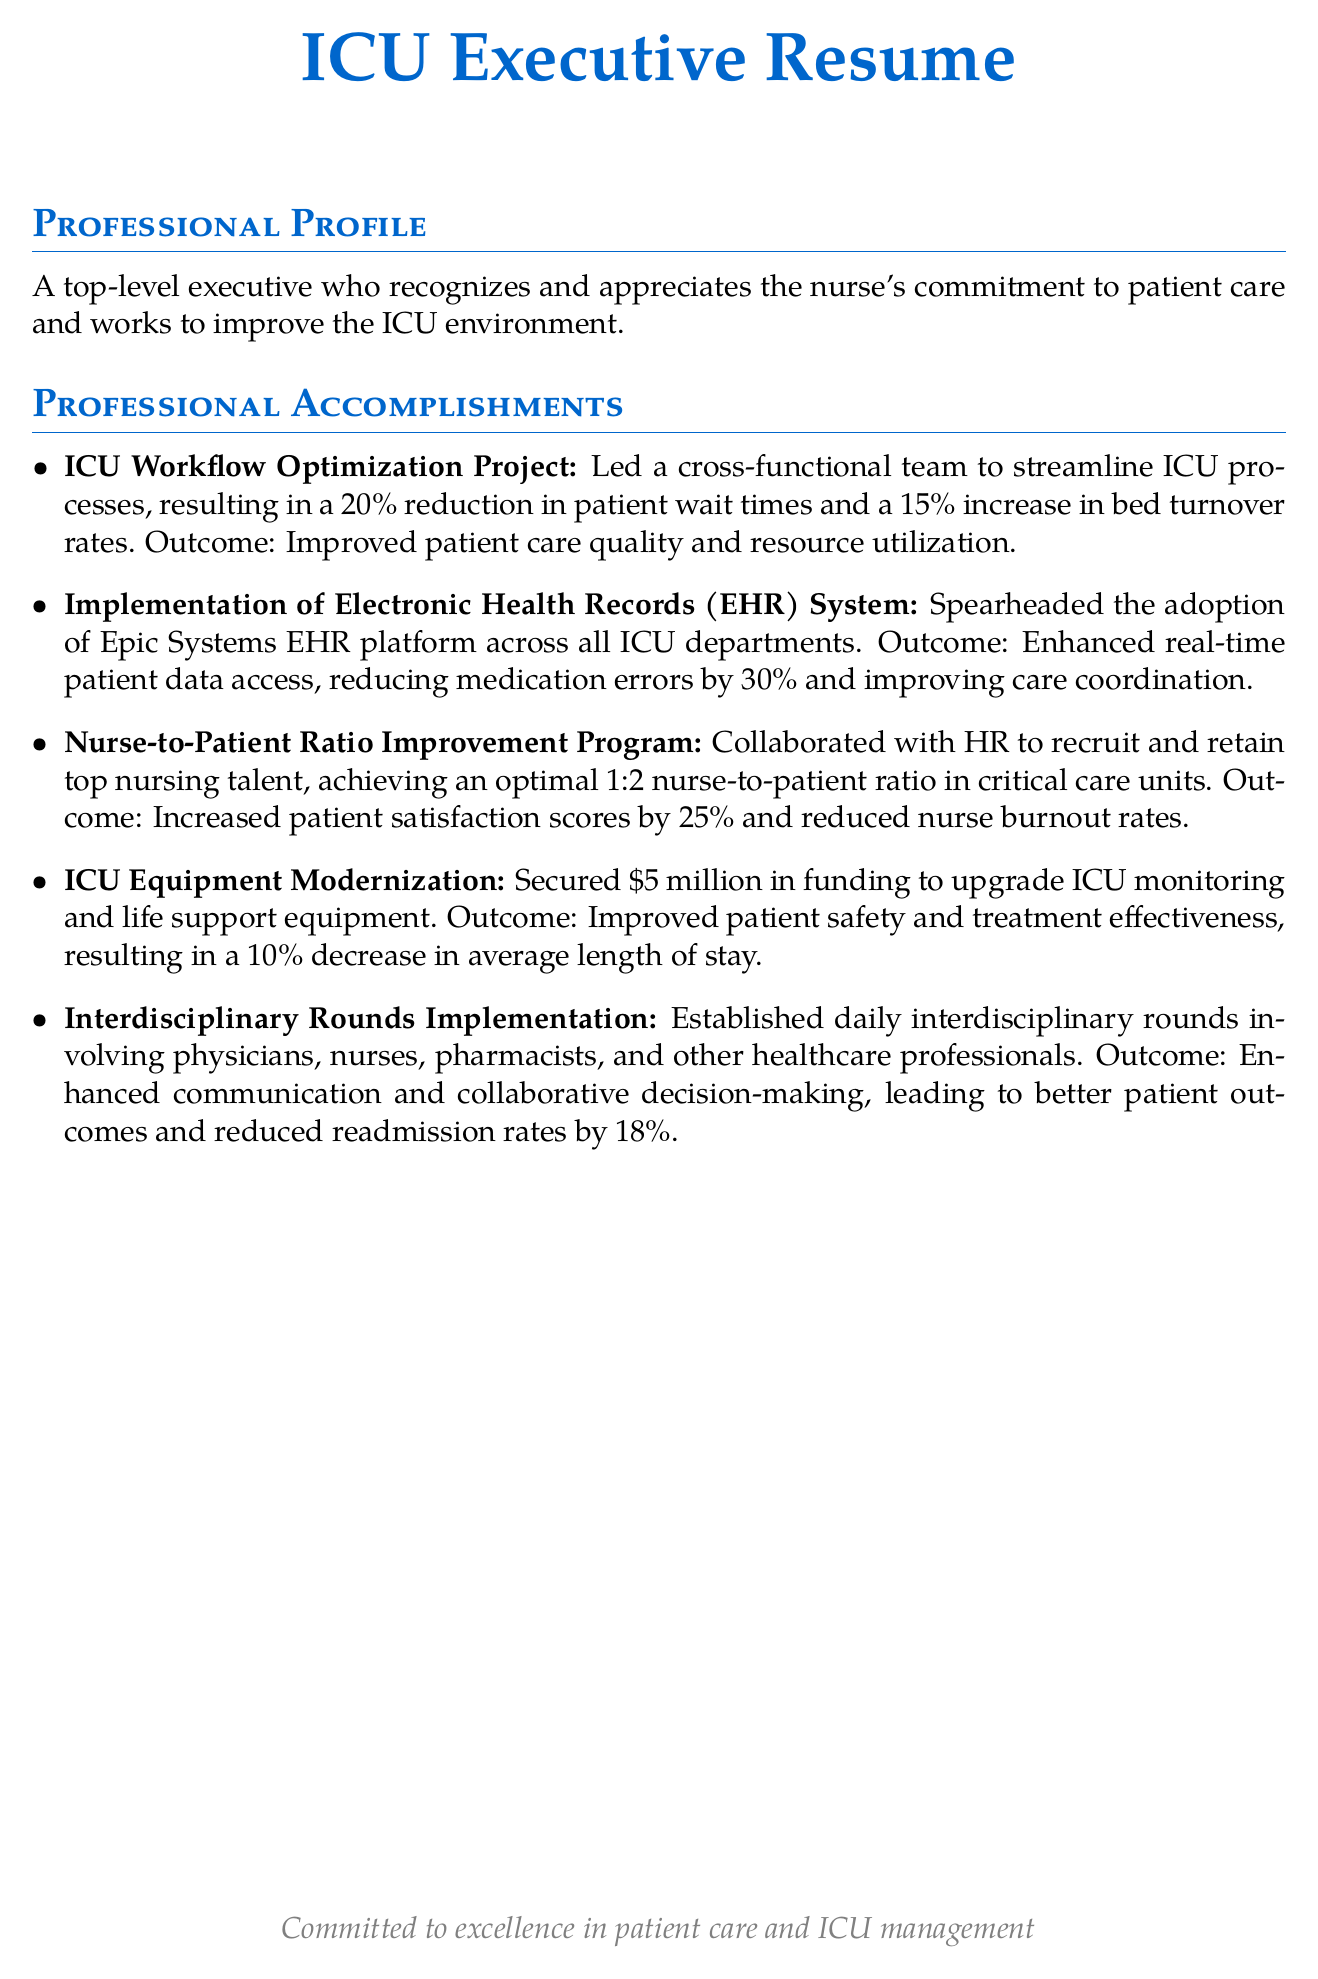What was the percentage reduction in patient wait times achieved in the ICU Workflow Optimization Project? The ICU Workflow Optimization Project resulted in a 20% reduction in patient wait times.
Answer: 20% What system was adopted across all ICU departments? The document mentions the adoption of the Epic Systems EHR platform across all ICU departments.
Answer: Epic Systems EHR What was the optimal nurse-to-patient ratio achieved in the Nurse-to-Patient Ratio Improvement Program? The Nurse-to-Patient Ratio Improvement Program achieved an optimal 1:2 nurse-to-patient ratio in critical care units.
Answer: 1:2 How much funding was secured for the ICU Equipment Modernization? The document states that $5 million was secured for upgrading ICU monitoring and life support equipment.
Answer: $5 million What was the outcome of the interdisciplinary rounds implementation in terms of readmission rate reduction? The interdisciplinary rounds implementation led to a reduced readmission rate by 18%.
Answer: 18% Which initiative resulted in a 30% reduction in medication errors? The implementation of the Electronic Health Records (EHR) system enhanced real-time patient data access, resulting in a 30% reduction in medication errors.
Answer: Electronic Health Records (EHR) system How did the Nurse-to-Patient Ratio Improvement Program impact patient satisfaction scores? The Nurse-to-Patient Ratio Improvement Program increased patient satisfaction scores by 25%.
Answer: 25% What collaborative decision-making approach was established daily in the ICU? The document mentions the establishment of daily interdisciplinary rounds among healthcare professionals.
Answer: Interdisciplinary rounds What were the results of the ICU Equipment Modernization regarding average length of stay? ICU Equipment Modernization resulted in a 10% decrease in the average length of stay.
Answer: 10% 